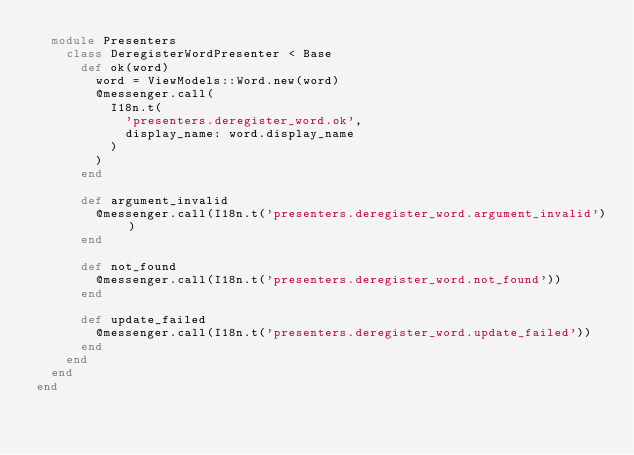Convert code to text. <code><loc_0><loc_0><loc_500><loc_500><_Ruby_>  module Presenters
    class DeregisterWordPresenter < Base
      def ok(word)
        word = ViewModels::Word.new(word)
        @messenger.call(
          I18n.t(
            'presenters.deregister_word.ok',
            display_name: word.display_name
          )
        )
      end

      def argument_invalid
        @messenger.call(I18n.t('presenters.deregister_word.argument_invalid'))
      end

      def not_found
        @messenger.call(I18n.t('presenters.deregister_word.not_found'))
      end

      def update_failed
        @messenger.call(I18n.t('presenters.deregister_word.update_failed'))
      end
    end
  end
end
</code> 